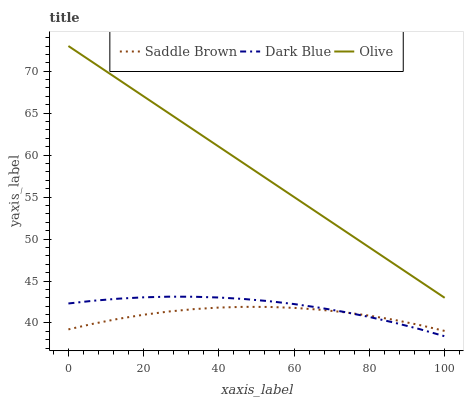Does Saddle Brown have the minimum area under the curve?
Answer yes or no. Yes. Does Olive have the maximum area under the curve?
Answer yes or no. Yes. Does Dark Blue have the minimum area under the curve?
Answer yes or no. No. Does Dark Blue have the maximum area under the curve?
Answer yes or no. No. Is Olive the smoothest?
Answer yes or no. Yes. Is Saddle Brown the roughest?
Answer yes or no. Yes. Is Dark Blue the smoothest?
Answer yes or no. No. Is Dark Blue the roughest?
Answer yes or no. No. Does Dark Blue have the lowest value?
Answer yes or no. Yes. Does Saddle Brown have the lowest value?
Answer yes or no. No. Does Olive have the highest value?
Answer yes or no. Yes. Does Dark Blue have the highest value?
Answer yes or no. No. Is Dark Blue less than Olive?
Answer yes or no. Yes. Is Olive greater than Saddle Brown?
Answer yes or no. Yes. Does Saddle Brown intersect Dark Blue?
Answer yes or no. Yes. Is Saddle Brown less than Dark Blue?
Answer yes or no. No. Is Saddle Brown greater than Dark Blue?
Answer yes or no. No. Does Dark Blue intersect Olive?
Answer yes or no. No. 